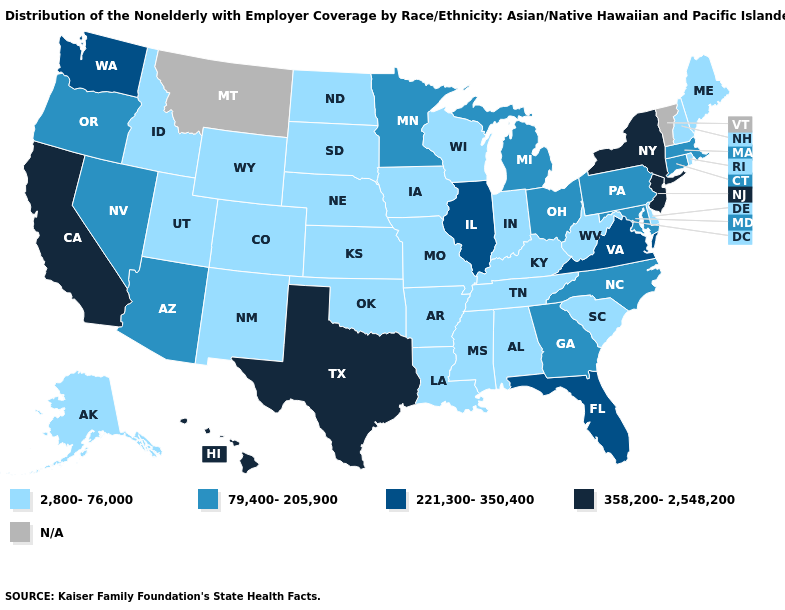What is the highest value in states that border Indiana?
Write a very short answer. 221,300-350,400. Name the states that have a value in the range 221,300-350,400?
Answer briefly. Florida, Illinois, Virginia, Washington. What is the value of Illinois?
Concise answer only. 221,300-350,400. What is the highest value in the West ?
Concise answer only. 358,200-2,548,200. What is the highest value in the MidWest ?
Write a very short answer. 221,300-350,400. Among the states that border Nebraska , which have the lowest value?
Be succinct. Colorado, Iowa, Kansas, Missouri, South Dakota, Wyoming. Among the states that border Michigan , does Wisconsin have the highest value?
Give a very brief answer. No. Among the states that border Nebraska , which have the lowest value?
Keep it brief. Colorado, Iowa, Kansas, Missouri, South Dakota, Wyoming. What is the value of Louisiana?
Answer briefly. 2,800-76,000. Which states hav the highest value in the West?
Keep it brief. California, Hawaii. Name the states that have a value in the range N/A?
Short answer required. Montana, Vermont. What is the highest value in the Northeast ?
Quick response, please. 358,200-2,548,200. Does West Virginia have the highest value in the USA?
Answer briefly. No. Is the legend a continuous bar?
Answer briefly. No. 